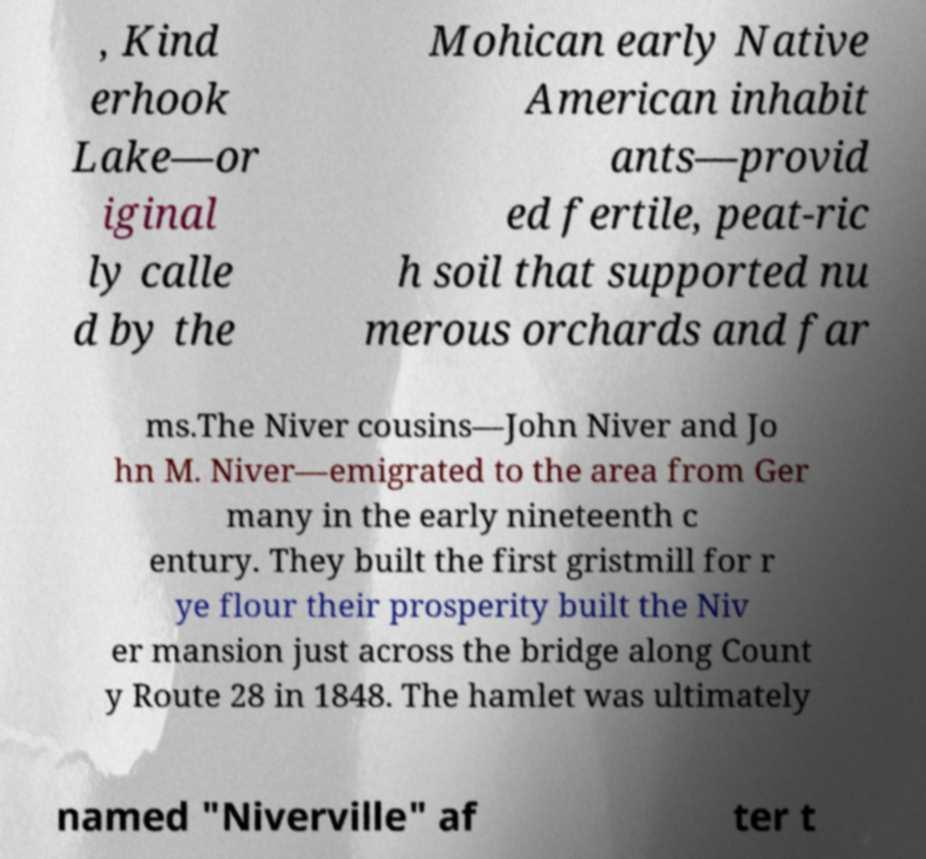Can you accurately transcribe the text from the provided image for me? , Kind erhook Lake—or iginal ly calle d by the Mohican early Native American inhabit ants—provid ed fertile, peat-ric h soil that supported nu merous orchards and far ms.The Niver cousins—John Niver and Jo hn M. Niver—emigrated to the area from Ger many in the early nineteenth c entury. They built the first gristmill for r ye flour their prosperity built the Niv er mansion just across the bridge along Count y Route 28 in 1848. The hamlet was ultimately named "Niverville" af ter t 